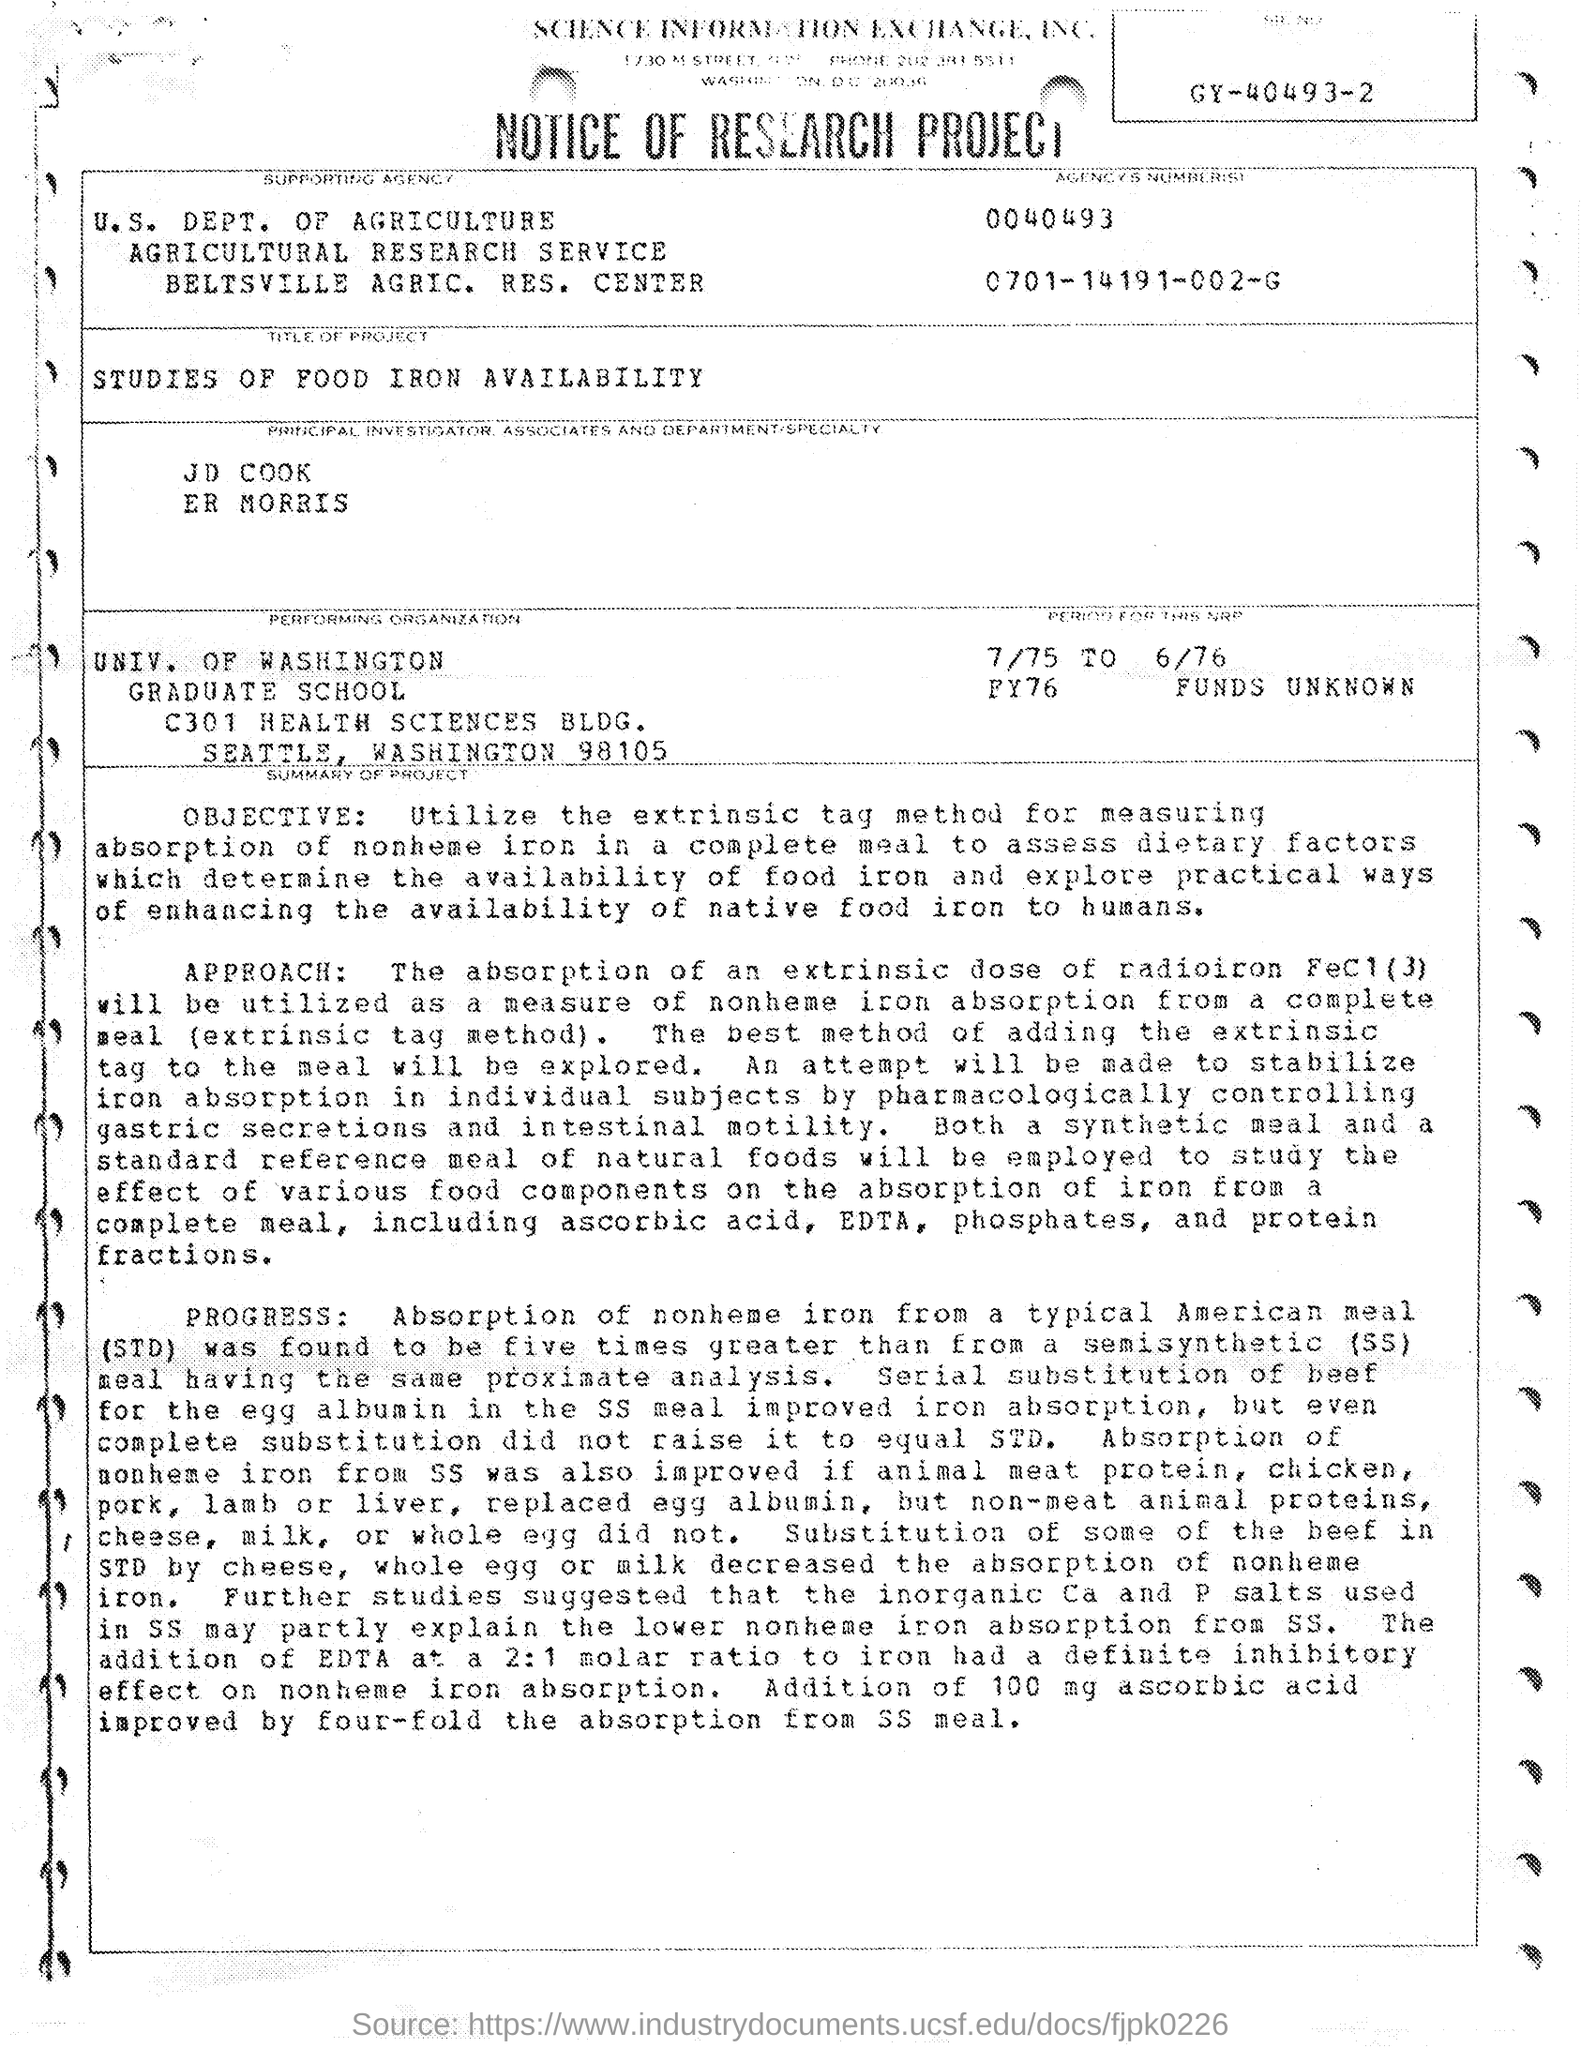Point out several critical features in this image. The University of Washington is the performing organization. The project is titled 'Studies of Food Iron Availability.' 